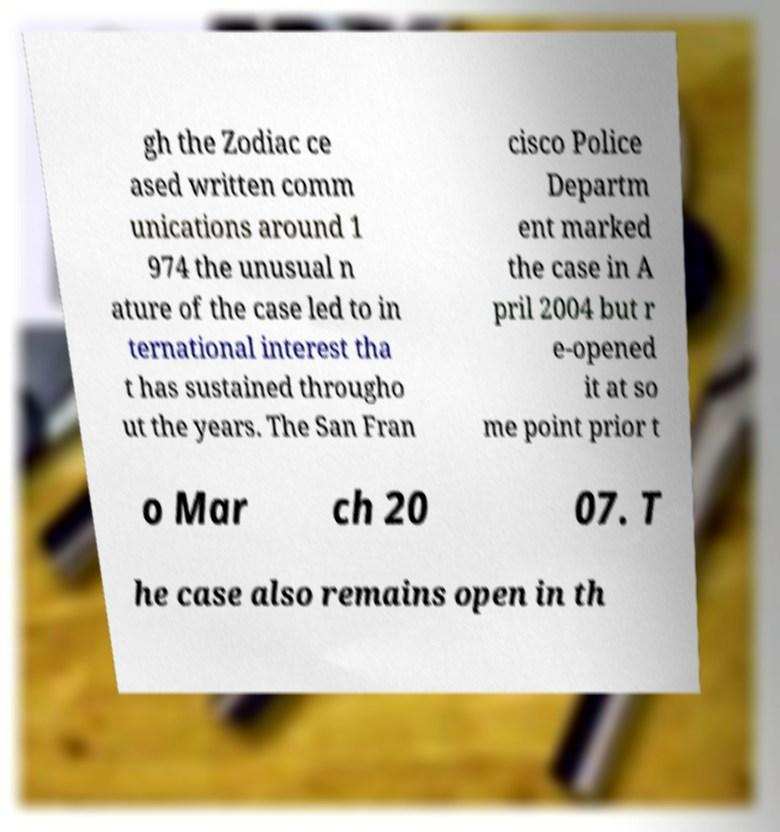I need the written content from this picture converted into text. Can you do that? gh the Zodiac ce ased written comm unications around 1 974 the unusual n ature of the case led to in ternational interest tha t has sustained througho ut the years. The San Fran cisco Police Departm ent marked the case in A pril 2004 but r e-opened it at so me point prior t o Mar ch 20 07. T he case also remains open in th 